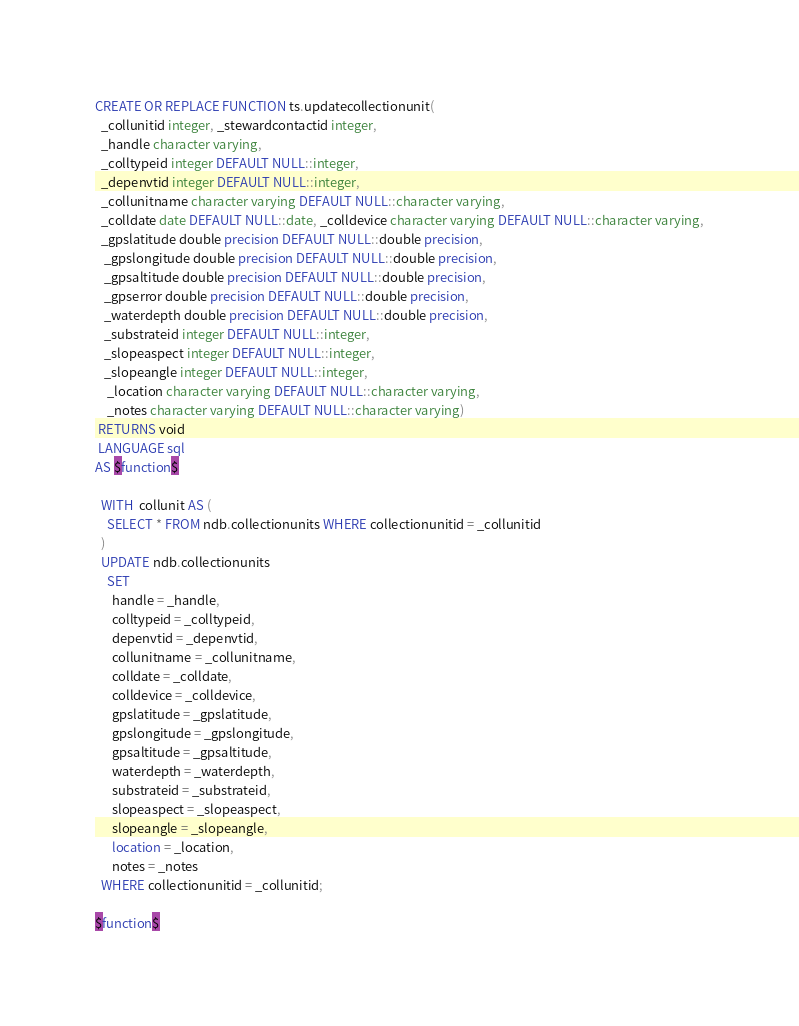Convert code to text. <code><loc_0><loc_0><loc_500><loc_500><_SQL_>CREATE OR REPLACE FUNCTION ts.updatecollectionunit(
  _collunitid integer, _stewardcontactid integer,
  _handle character varying,
  _colltypeid integer DEFAULT NULL::integer,
  _depenvtid integer DEFAULT NULL::integer,
  _collunitname character varying DEFAULT NULL::character varying,
  _colldate date DEFAULT NULL::date, _colldevice character varying DEFAULT NULL::character varying,
  _gpslatitude double precision DEFAULT NULL::double precision,
   _gpslongitude double precision DEFAULT NULL::double precision,
   _gpsaltitude double precision DEFAULT NULL::double precision, 
   _gpserror double precision DEFAULT NULL::double precision,
   _waterdepth double precision DEFAULT NULL::double precision,
   _substrateid integer DEFAULT NULL::integer,
   _slopeaspect integer DEFAULT NULL::integer,
   _slopeangle integer DEFAULT NULL::integer,
    _location character varying DEFAULT NULL::character varying,
    _notes character varying DEFAULT NULL::character varying)
 RETURNS void
 LANGUAGE sql
AS $function$

  WITH  collunit AS (
    SELECT * FROM ndb.collectionunits WHERE collectionunitid = _collunitid
  )
  UPDATE ndb.collectionunits
    SET
      handle = _handle,
      colltypeid = _colltypeid,
      depenvtid = _depenvtid,
      collunitname = _collunitname,
      colldate = _colldate,
      colldevice = _colldevice,
      gpslatitude = _gpslatitude,
      gpslongitude = _gpslongitude,
      gpsaltitude = _gpsaltitude,
      waterdepth = _waterdepth,
      substrateid = _substrateid,
      slopeaspect = _slopeaspect,
      slopeangle = _slopeangle,
      location = _location,
      notes = _notes
  WHERE collectionunitid = _collunitid;

$function$
</code> 